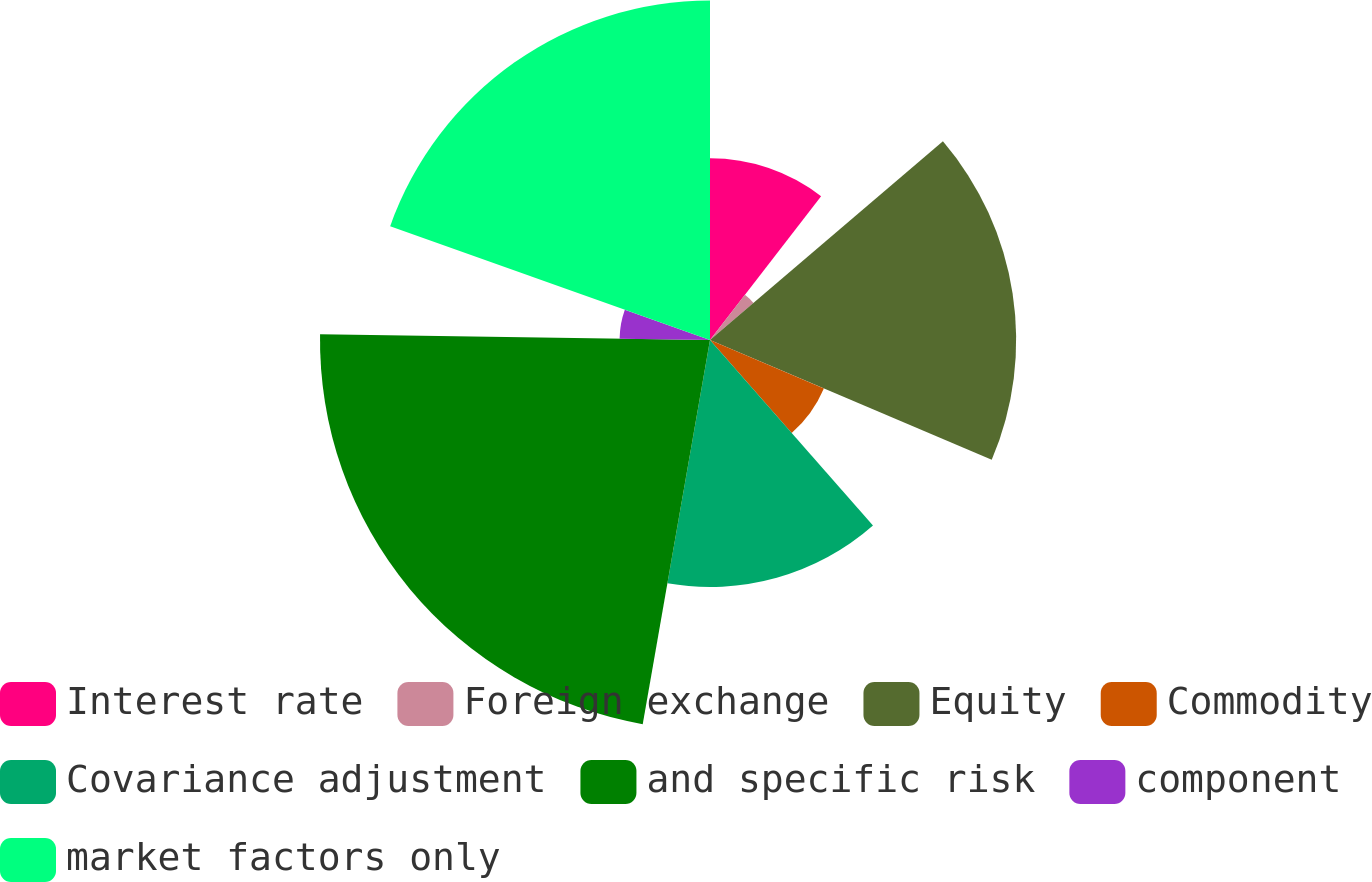Convert chart. <chart><loc_0><loc_0><loc_500><loc_500><pie_chart><fcel>Interest rate<fcel>Foreign exchange<fcel>Equity<fcel>Commodity<fcel>Covariance adjustment<fcel>and specific risk<fcel>component<fcel>market factors only<nl><fcel>10.47%<fcel>3.29%<fcel>17.64%<fcel>7.13%<fcel>14.23%<fcel>22.47%<fcel>5.21%<fcel>19.56%<nl></chart> 